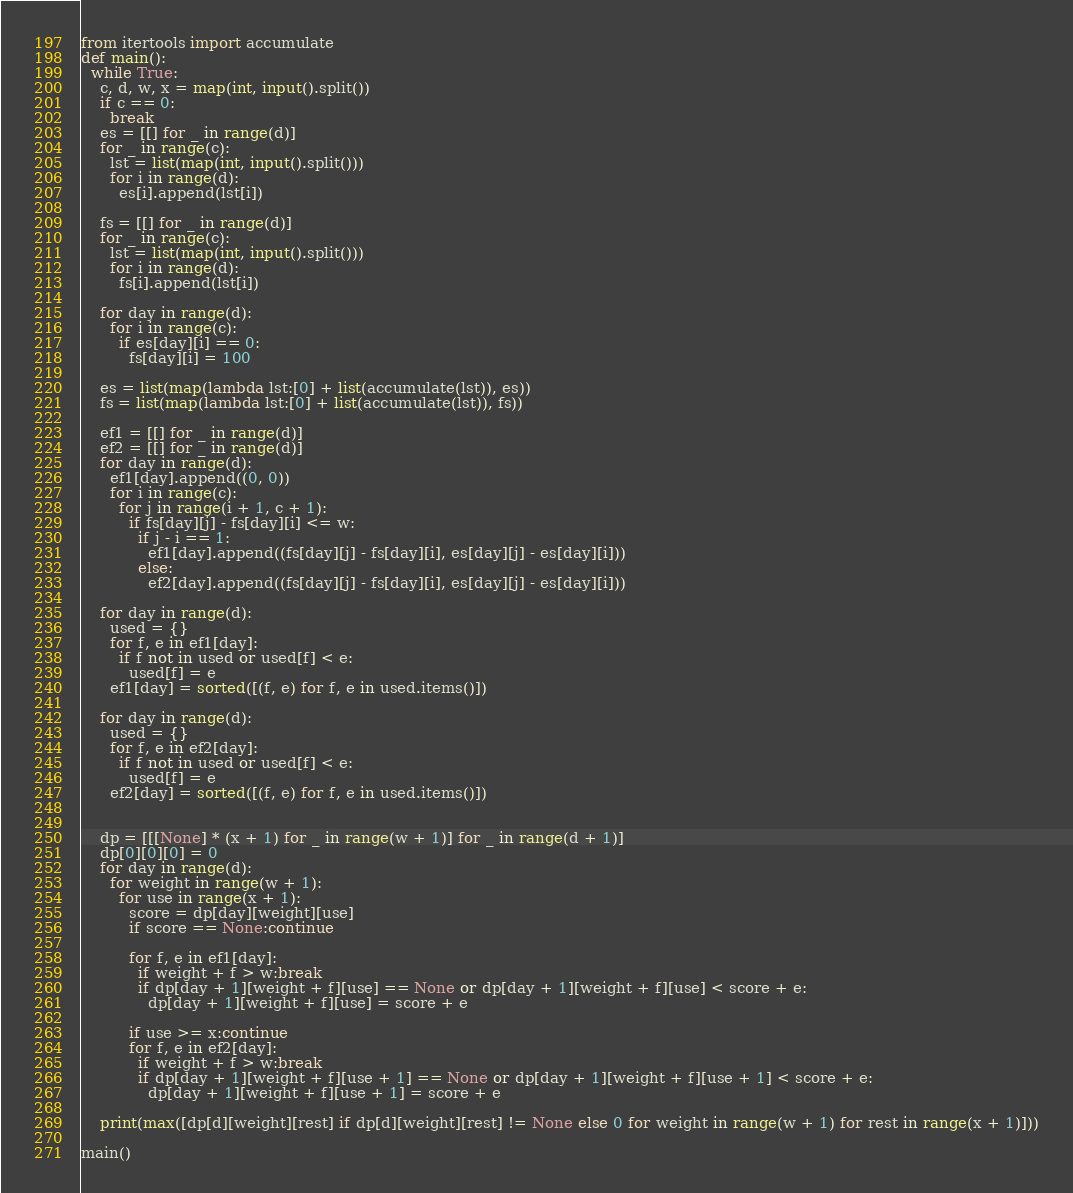Convert code to text. <code><loc_0><loc_0><loc_500><loc_500><_Python_>from itertools import accumulate
def main():
  while True:
    c, d, w, x = map(int, input().split())
    if c == 0:
      break
    es = [[] for _ in range(d)]
    for _ in range(c):
      lst = list(map(int, input().split()))
      for i in range(d):
        es[i].append(lst[i])
    
    fs = [[] for _ in range(d)]
    for _ in range(c):
      lst = list(map(int, input().split()))
      for i in range(d):
        fs[i].append(lst[i])
  
    for day in range(d):
      for i in range(c):
        if es[day][i] == 0:
          fs[day][i] = 100
  
    es = list(map(lambda lst:[0] + list(accumulate(lst)), es))
    fs = list(map(lambda lst:[0] + list(accumulate(lst)), fs))
  
    ef1 = [[] for _ in range(d)]
    ef2 = [[] for _ in range(d)]
    for day in range(d):
      ef1[day].append((0, 0))
      for i in range(c):
        for j in range(i + 1, c + 1):
          if fs[day][j] - fs[day][i] <= w:
            if j - i == 1:
              ef1[day].append((fs[day][j] - fs[day][i], es[day][j] - es[day][i]))
            else:
              ef2[day].append((fs[day][j] - fs[day][i], es[day][j] - es[day][i]))
    
    for day in range(d):   
      used = {}
      for f, e in ef1[day]:
        if f not in used or used[f] < e:
          used[f] = e
      ef1[day] = sorted([(f, e) for f, e in used.items()])
    
    for day in range(d):
      used = {}
      for f, e in ef2[day]:
        if f not in used or used[f] < e:
          used[f] = e
      ef2[day] = sorted([(f, e) for f, e in used.items()])


    dp = [[[None] * (x + 1) for _ in range(w + 1)] for _ in range(d + 1)]
    dp[0][0][0] = 0
    for day in range(d):
      for weight in range(w + 1):
        for use in range(x + 1):
          score = dp[day][weight][use]
          if score == None:continue
          
          for f, e in ef1[day]:
            if weight + f > w:break
            if dp[day + 1][weight + f][use] == None or dp[day + 1][weight + f][use] < score + e:
              dp[day + 1][weight + f][use] = score + e
          
          if use >= x:continue
          for f, e in ef2[day]:
            if weight + f > w:break
            if dp[day + 1][weight + f][use + 1] == None or dp[day + 1][weight + f][use + 1] < score + e:
              dp[day + 1][weight + f][use + 1] = score + e
  
    print(max([dp[d][weight][rest] if dp[d][weight][rest] != None else 0 for weight in range(w + 1) for rest in range(x + 1)]))

main()
</code> 